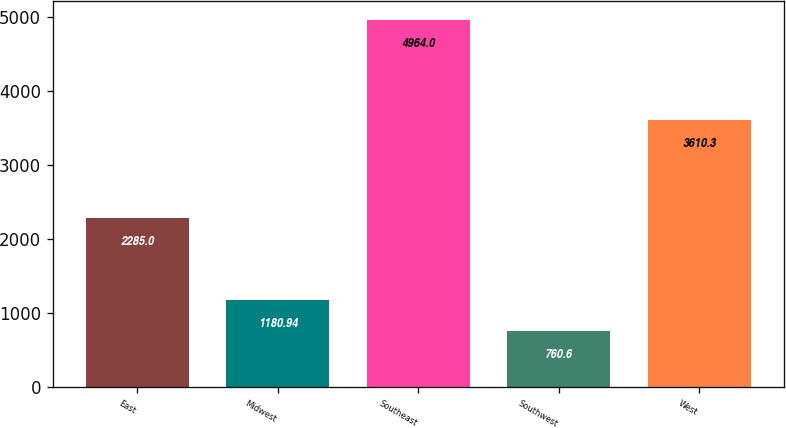<chart> <loc_0><loc_0><loc_500><loc_500><bar_chart><fcel>East<fcel>Midwest<fcel>Southeast<fcel>Southwest<fcel>West<nl><fcel>2285<fcel>1180.94<fcel>4964<fcel>760.6<fcel>3610.3<nl></chart> 